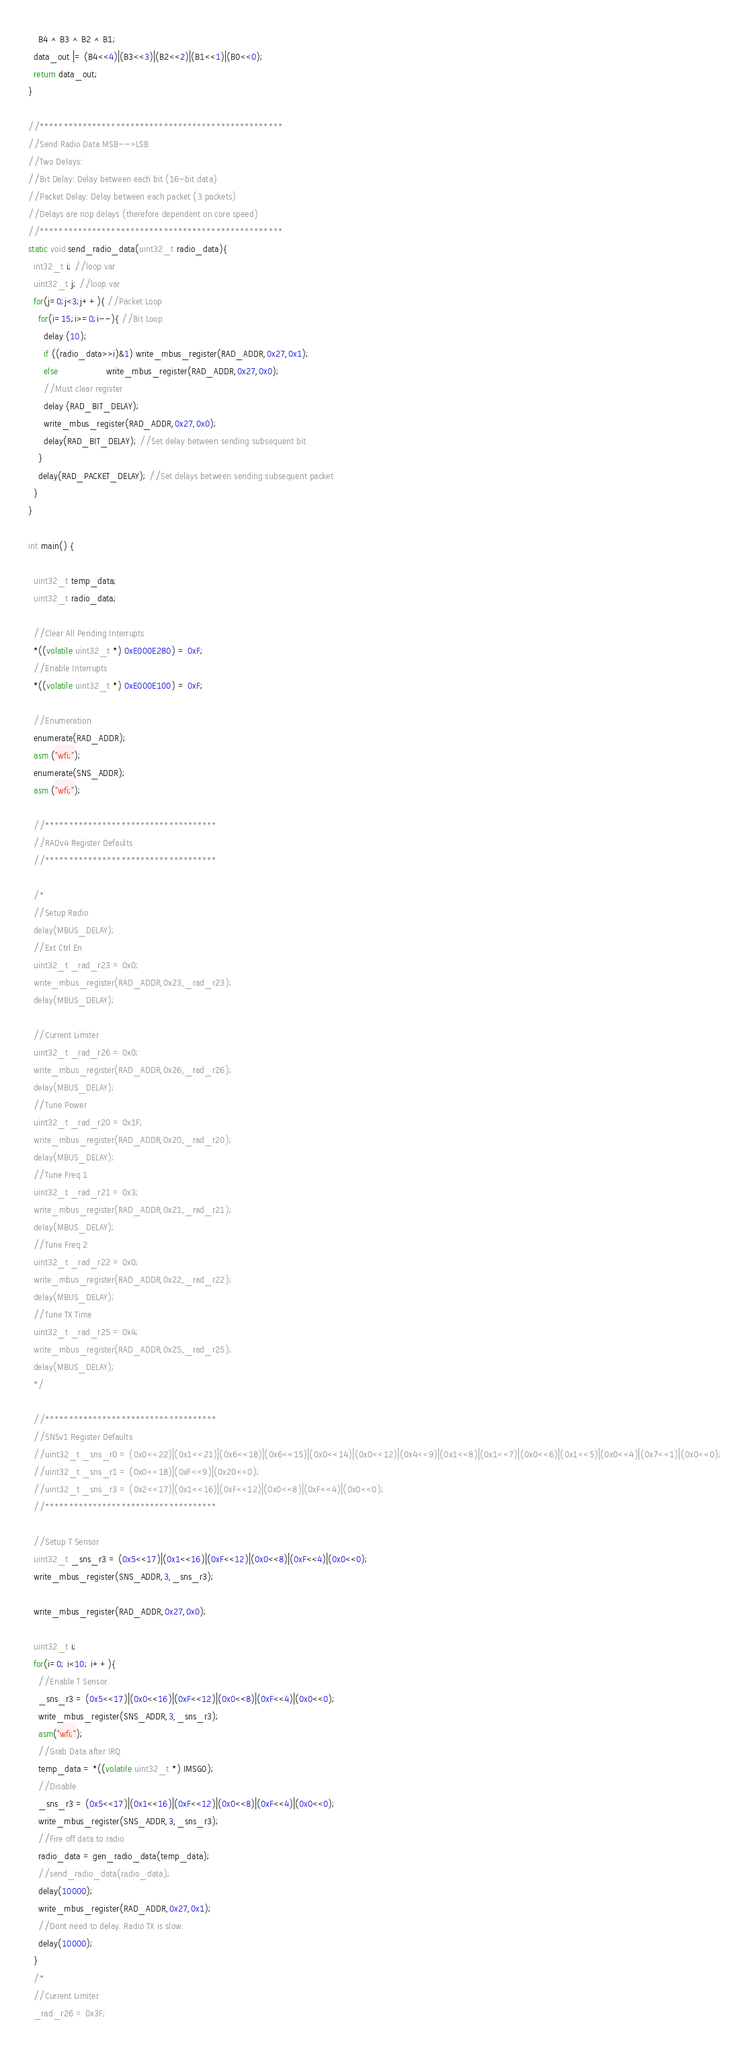Convert code to text. <code><loc_0><loc_0><loc_500><loc_500><_C_>    B4 ^ B3 ^ B2 ^ B1;
  data_out |= (B4<<4)|(B3<<3)|(B2<<2)|(B1<<1)|(B0<<0);
  return data_out;
}

//***************************************************
//Send Radio Data MSB-->LSB
//Two Delays:
//Bit Delay: Delay between each bit (16-bit data)
//Packet Delay: Delay between each packet (3 packets)
//Delays are nop delays (therefore dependent on core speed)
//***************************************************
static void send_radio_data(uint32_t radio_data){
  int32_t i; //loop var
  uint32_t j; //loop var
  for(j=0;j<3;j++){ //Packet Loop
    for(i=15;i>=0;i--){ //Bit Loop
      delay (10);
      if ((radio_data>>i)&1) write_mbus_register(RAD_ADDR,0x27,0x1);
      else                   write_mbus_register(RAD_ADDR,0x27,0x0);
      //Must clear register
      delay (RAD_BIT_DELAY);
      write_mbus_register(RAD_ADDR,0x27,0x0);
      delay(RAD_BIT_DELAY); //Set delay between sending subsequent bit
    }
    delay(RAD_PACKET_DELAY); //Set delays between sending subsequent packet
  }
}

int main() {

  uint32_t temp_data;
  uint32_t radio_data;
  
  //Clear All Pending Interrupts
  *((volatile uint32_t *) 0xE000E280) = 0xF;
  //Enable Interrupts
  *((volatile uint32_t *) 0xE000E100) = 0xF;

  //Enumeration
  enumerate(RAD_ADDR);
  asm ("wfi;");
  enumerate(SNS_ADDR);
  asm ("wfi;");

  //************************************
  //RADv4 Register Defaults
  //************************************

  /*
  //Setup Radio
  delay(MBUS_DELAY);
  //Ext Ctrl En
  uint32_t _rad_r23 = 0x0;
  write_mbus_register(RAD_ADDR,0x23,_rad_r23);
  delay(MBUS_DELAY);

  //Current Limiter
  uint32_t _rad_r26 = 0x0;
  write_mbus_register(RAD_ADDR,0x26,_rad_r26);
  delay(MBUS_DELAY);
  //Tune Power
  uint32_t _rad_r20 = 0x1F;
  write_mbus_register(RAD_ADDR,0x20,_rad_r20);
  delay(MBUS_DELAY);
  //Tune Freq 1
  uint32_t _rad_r21 = 0x3;
  write_mbus_register(RAD_ADDR,0x21,_rad_r21);
  delay(MBUS_DELAY);
  //Tune Freq 2
  uint32_t _rad_r22 = 0x0;
  write_mbus_register(RAD_ADDR,0x22,_rad_r22);
  delay(MBUS_DELAY);
  //Tune TX Time
  uint32_t _rad_r25 = 0x4;
  write_mbus_register(RAD_ADDR,0x25,_rad_r25);
  delay(MBUS_DELAY);
  */

  //************************************
  //SNSv1 Register Defaults
  //uint32_t _sns_r0 = (0x0<<22)|(0x1<<21)|(0x6<<18)|(0x6<<15)|(0x0<<14)|(0x0<<12)|(0x4<<9)|(0x1<<8)|(0x1<<7)|(0x0<<6)|(0x1<<5)|(0x0<<4)|(0x7<<1)|(0x0<<0);
  //uint32_t _sns_r1 = (0x0<<18)|(0xF<<9)|(0x20<<0);
  //uint32_t _sns_r3 = (0x2<<17)|(0x1<<16)|(0xF<<12)|(0x0<<8)|(0xF<<4)|(0x0<<0);
  //************************************

  //Setup T Sensor
  uint32_t _sns_r3 = (0x5<<17)|(0x1<<16)|(0xF<<12)|(0x0<<8)|(0xF<<4)|(0x0<<0);
  write_mbus_register(SNS_ADDR,3,_sns_r3);

  write_mbus_register(RAD_ADDR,0x27,0x0);

  uint32_t i;
  for(i=0; i<10; i++){
    //Enable T Sensor
    _sns_r3 = (0x5<<17)|(0x0<<16)|(0xF<<12)|(0x0<<8)|(0xF<<4)|(0x0<<0);
    write_mbus_register(SNS_ADDR,3,_sns_r3);
    asm("wfi;");
    //Grab Data after IRQ
    temp_data = *((volatile uint32_t *) IMSG0);
    //Disable
    _sns_r3 = (0x5<<17)|(0x1<<16)|(0xF<<12)|(0x0<<8)|(0xF<<4)|(0x0<<0);
    write_mbus_register(SNS_ADDR,3,_sns_r3);
    //Fire off data to radio
    radio_data = gen_radio_data(temp_data);
    //send_radio_data(radio_data);
    delay(10000);
    write_mbus_register(RAD_ADDR,0x27,0x1);
    //Dont need to delay. Radio TX is slow.
    delay(10000);
  }
  /*
  //Current Limiter
  _rad_r26 = 0x3F;</code> 